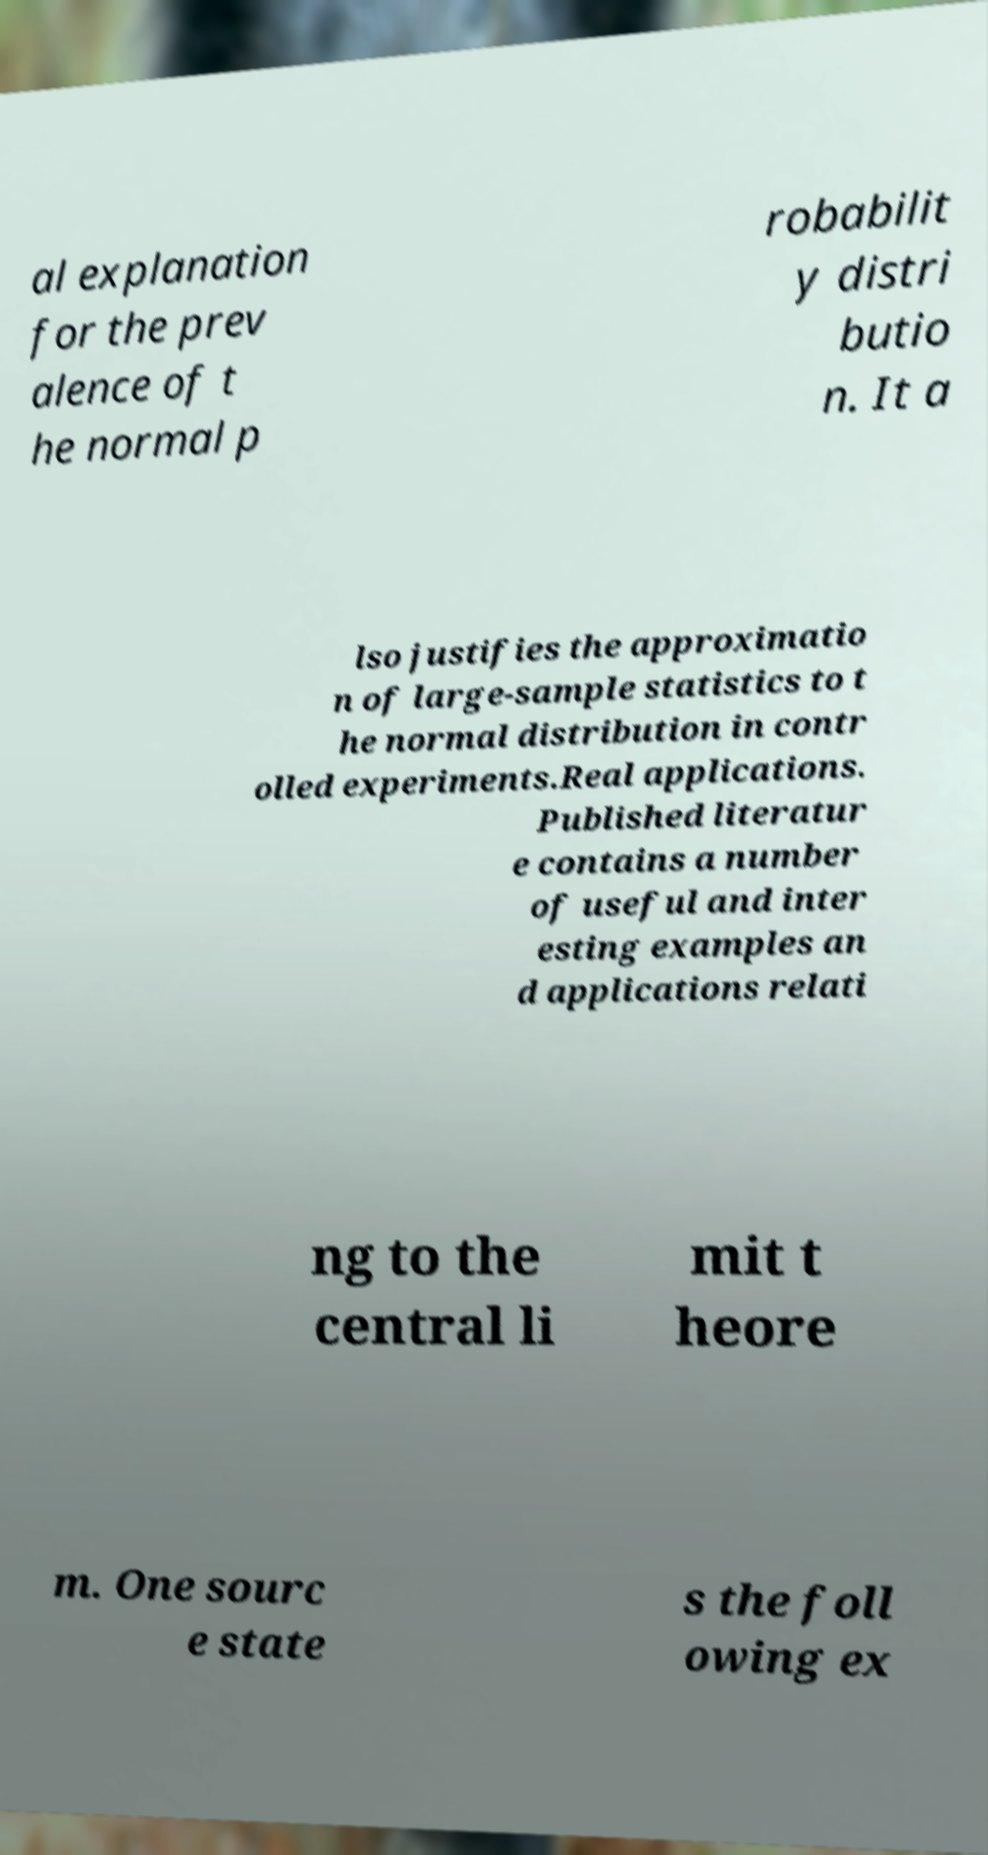There's text embedded in this image that I need extracted. Can you transcribe it verbatim? al explanation for the prev alence of t he normal p robabilit y distri butio n. It a lso justifies the approximatio n of large-sample statistics to t he normal distribution in contr olled experiments.Real applications. Published literatur e contains a number of useful and inter esting examples an d applications relati ng to the central li mit t heore m. One sourc e state s the foll owing ex 